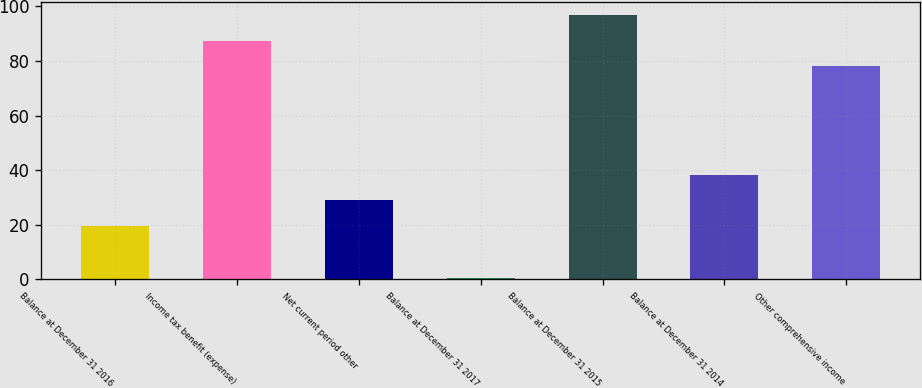Convert chart to OTSL. <chart><loc_0><loc_0><loc_500><loc_500><bar_chart><fcel>Balance at December 31 2016<fcel>Income tax benefit (expense)<fcel>Net current period other<fcel>Balance at December 31 2017<fcel>Balance at December 31 2015<fcel>Balance at December 31 2014<fcel>Other comprehensive income<nl><fcel>19.5<fcel>87.44<fcel>28.94<fcel>0.6<fcel>96.88<fcel>38.38<fcel>78<nl></chart> 